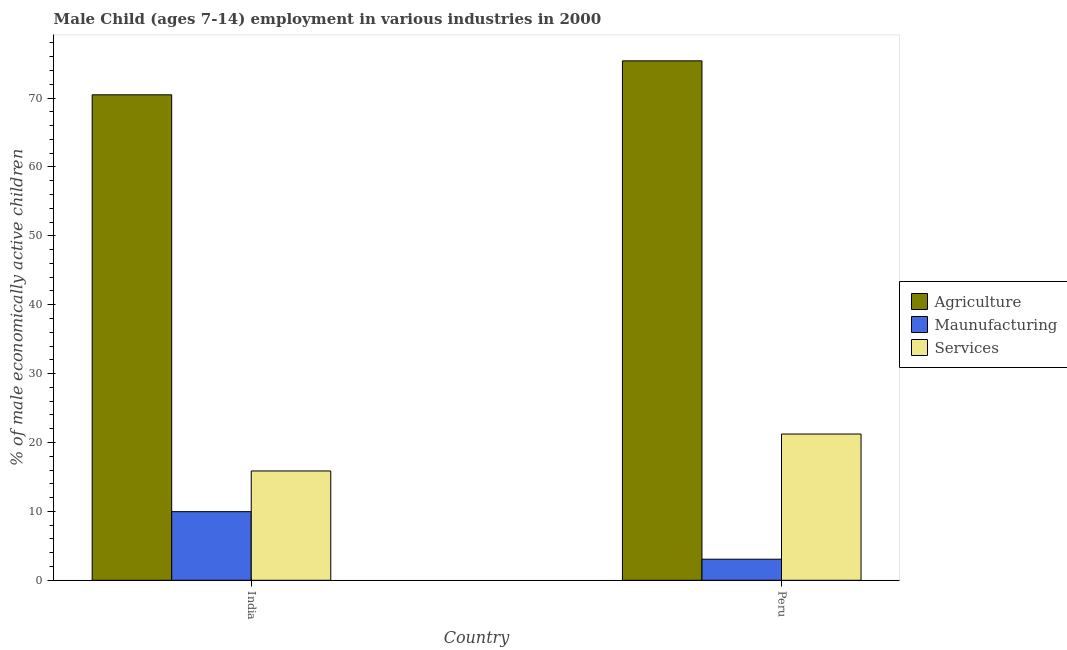How many groups of bars are there?
Keep it short and to the point. 2. How many bars are there on the 2nd tick from the left?
Ensure brevity in your answer.  3. How many bars are there on the 1st tick from the right?
Make the answer very short. 3. What is the label of the 1st group of bars from the left?
Provide a succinct answer. India. What is the percentage of economically active children in services in Peru?
Keep it short and to the point. 21.23. Across all countries, what is the maximum percentage of economically active children in agriculture?
Your answer should be compact. 75.4. Across all countries, what is the minimum percentage of economically active children in agriculture?
Make the answer very short. 70.47. In which country was the percentage of economically active children in agriculture maximum?
Ensure brevity in your answer.  Peru. What is the total percentage of economically active children in agriculture in the graph?
Provide a succinct answer. 145.87. What is the difference between the percentage of economically active children in agriculture in India and that in Peru?
Offer a very short reply. -4.93. What is the difference between the percentage of economically active children in services in Peru and the percentage of economically active children in manufacturing in India?
Your answer should be very brief. 11.27. What is the average percentage of economically active children in manufacturing per country?
Your response must be concise. 6.51. What is the difference between the percentage of economically active children in services and percentage of economically active children in agriculture in India?
Give a very brief answer. -54.6. What is the ratio of the percentage of economically active children in services in India to that in Peru?
Your answer should be very brief. 0.75. In how many countries, is the percentage of economically active children in agriculture greater than the average percentage of economically active children in agriculture taken over all countries?
Keep it short and to the point. 1. What does the 2nd bar from the left in India represents?
Provide a succinct answer. Maunufacturing. What does the 2nd bar from the right in India represents?
Your response must be concise. Maunufacturing. How many bars are there?
Make the answer very short. 6. Are all the bars in the graph horizontal?
Keep it short and to the point. No. How many countries are there in the graph?
Offer a terse response. 2. What is the difference between two consecutive major ticks on the Y-axis?
Provide a short and direct response. 10. Are the values on the major ticks of Y-axis written in scientific E-notation?
Offer a very short reply. No. Does the graph contain grids?
Your answer should be compact. No. What is the title of the graph?
Make the answer very short. Male Child (ages 7-14) employment in various industries in 2000. What is the label or title of the Y-axis?
Give a very brief answer. % of male economically active children. What is the % of male economically active children in Agriculture in India?
Offer a terse response. 70.47. What is the % of male economically active children in Maunufacturing in India?
Offer a very short reply. 9.96. What is the % of male economically active children of Services in India?
Your answer should be compact. 15.87. What is the % of male economically active children of Agriculture in Peru?
Keep it short and to the point. 75.4. What is the % of male economically active children in Maunufacturing in Peru?
Offer a very short reply. 3.06. What is the % of male economically active children of Services in Peru?
Ensure brevity in your answer.  21.23. Across all countries, what is the maximum % of male economically active children of Agriculture?
Offer a very short reply. 75.4. Across all countries, what is the maximum % of male economically active children of Maunufacturing?
Offer a terse response. 9.96. Across all countries, what is the maximum % of male economically active children of Services?
Keep it short and to the point. 21.23. Across all countries, what is the minimum % of male economically active children in Agriculture?
Ensure brevity in your answer.  70.47. Across all countries, what is the minimum % of male economically active children in Maunufacturing?
Offer a very short reply. 3.06. Across all countries, what is the minimum % of male economically active children in Services?
Provide a short and direct response. 15.87. What is the total % of male economically active children of Agriculture in the graph?
Give a very brief answer. 145.87. What is the total % of male economically active children in Maunufacturing in the graph?
Offer a terse response. 13.02. What is the total % of male economically active children in Services in the graph?
Ensure brevity in your answer.  37.1. What is the difference between the % of male economically active children in Agriculture in India and that in Peru?
Offer a very short reply. -4.93. What is the difference between the % of male economically active children in Services in India and that in Peru?
Ensure brevity in your answer.  -5.36. What is the difference between the % of male economically active children of Agriculture in India and the % of male economically active children of Maunufacturing in Peru?
Make the answer very short. 67.41. What is the difference between the % of male economically active children of Agriculture in India and the % of male economically active children of Services in Peru?
Your answer should be very brief. 49.24. What is the difference between the % of male economically active children of Maunufacturing in India and the % of male economically active children of Services in Peru?
Provide a succinct answer. -11.27. What is the average % of male economically active children in Agriculture per country?
Your answer should be compact. 72.94. What is the average % of male economically active children of Maunufacturing per country?
Ensure brevity in your answer.  6.51. What is the average % of male economically active children in Services per country?
Provide a short and direct response. 18.55. What is the difference between the % of male economically active children in Agriculture and % of male economically active children in Maunufacturing in India?
Provide a short and direct response. 60.51. What is the difference between the % of male economically active children of Agriculture and % of male economically active children of Services in India?
Offer a very short reply. 54.6. What is the difference between the % of male economically active children in Maunufacturing and % of male economically active children in Services in India?
Offer a terse response. -5.91. What is the difference between the % of male economically active children of Agriculture and % of male economically active children of Maunufacturing in Peru?
Offer a terse response. 72.34. What is the difference between the % of male economically active children of Agriculture and % of male economically active children of Services in Peru?
Your answer should be very brief. 54.17. What is the difference between the % of male economically active children in Maunufacturing and % of male economically active children in Services in Peru?
Your answer should be compact. -18.17. What is the ratio of the % of male economically active children of Agriculture in India to that in Peru?
Your answer should be compact. 0.93. What is the ratio of the % of male economically active children of Maunufacturing in India to that in Peru?
Ensure brevity in your answer.  3.25. What is the ratio of the % of male economically active children in Services in India to that in Peru?
Your response must be concise. 0.75. What is the difference between the highest and the second highest % of male economically active children of Agriculture?
Your response must be concise. 4.93. What is the difference between the highest and the second highest % of male economically active children in Services?
Offer a very short reply. 5.36. What is the difference between the highest and the lowest % of male economically active children of Agriculture?
Give a very brief answer. 4.93. What is the difference between the highest and the lowest % of male economically active children in Services?
Make the answer very short. 5.36. 